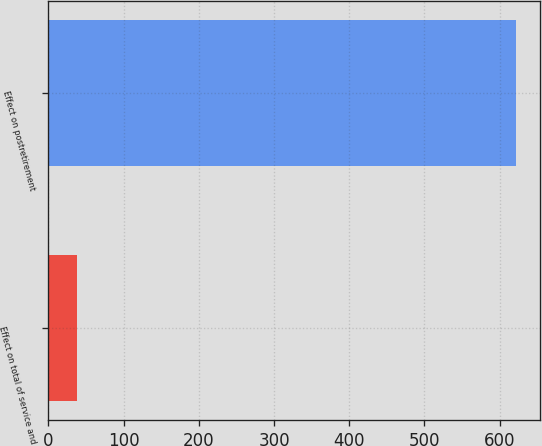Convert chart. <chart><loc_0><loc_0><loc_500><loc_500><bar_chart><fcel>Effect on total of service and<fcel>Effect on postretirement<nl><fcel>38<fcel>622<nl></chart> 